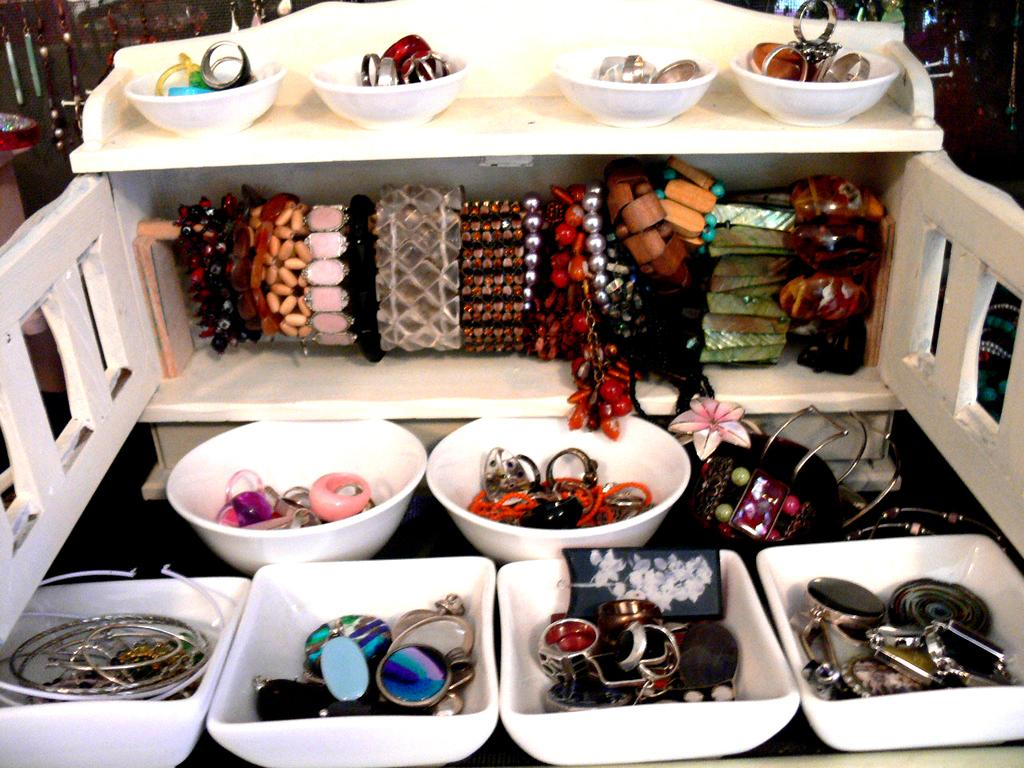What type of objects can be seen in the image? There are objects in bowls in the image. What is the color of the bowls? The bowls are white in color. How many laborers are working on the paste in the image? There is no mention of laborers or paste in the image; it only features objects in white bowls. 